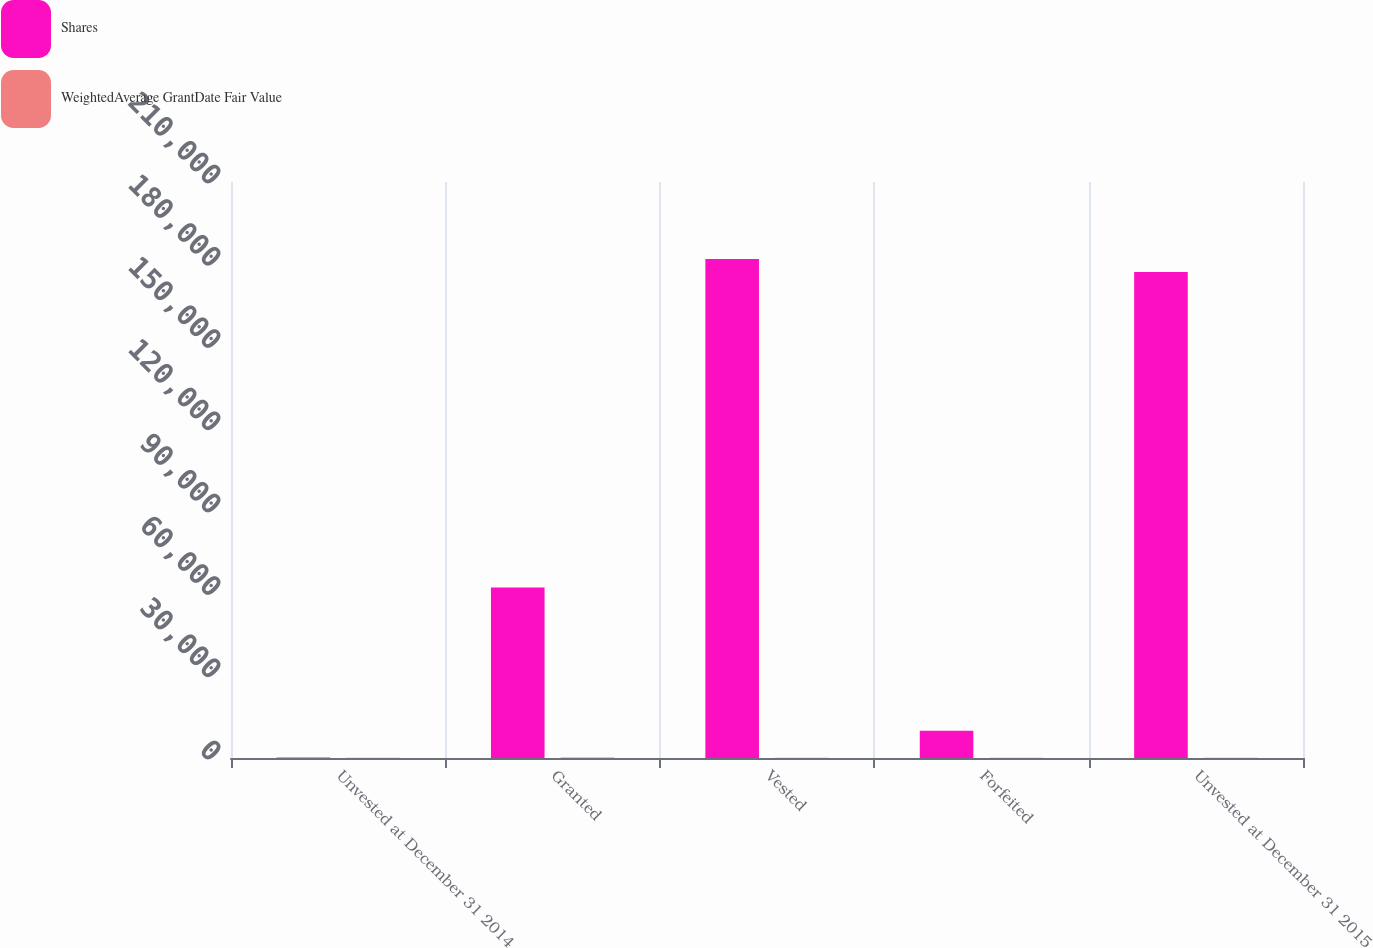<chart> <loc_0><loc_0><loc_500><loc_500><stacked_bar_chart><ecel><fcel>Unvested at December 31 2014<fcel>Granted<fcel>Vested<fcel>Forfeited<fcel>Unvested at December 31 2015<nl><fcel>Shares<fcel>141.08<fcel>62128<fcel>181967<fcel>9915<fcel>177214<nl><fcel>WeightedAverage GrantDate Fair Value<fcel>100.45<fcel>141.08<fcel>95.99<fcel>111.21<fcel>118.68<nl></chart> 